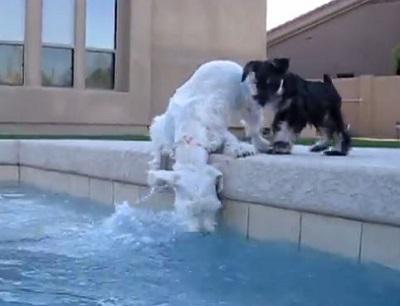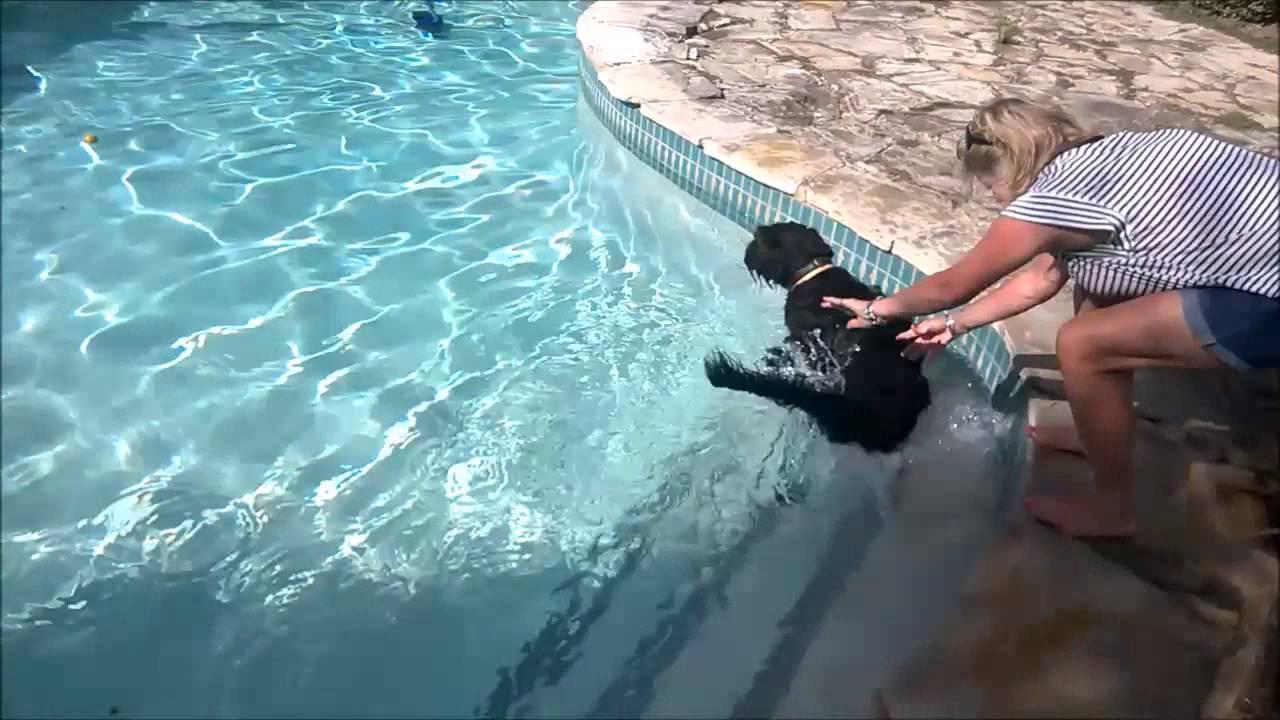The first image is the image on the left, the second image is the image on the right. Evaluate the accuracy of this statement regarding the images: "Exactly one dog is partly in the water.". Is it true? Answer yes or no. No. The first image is the image on the left, the second image is the image on the right. For the images shown, is this caption "two dogs are on the side of the pool looking at the water" true? Answer yes or no. Yes. 